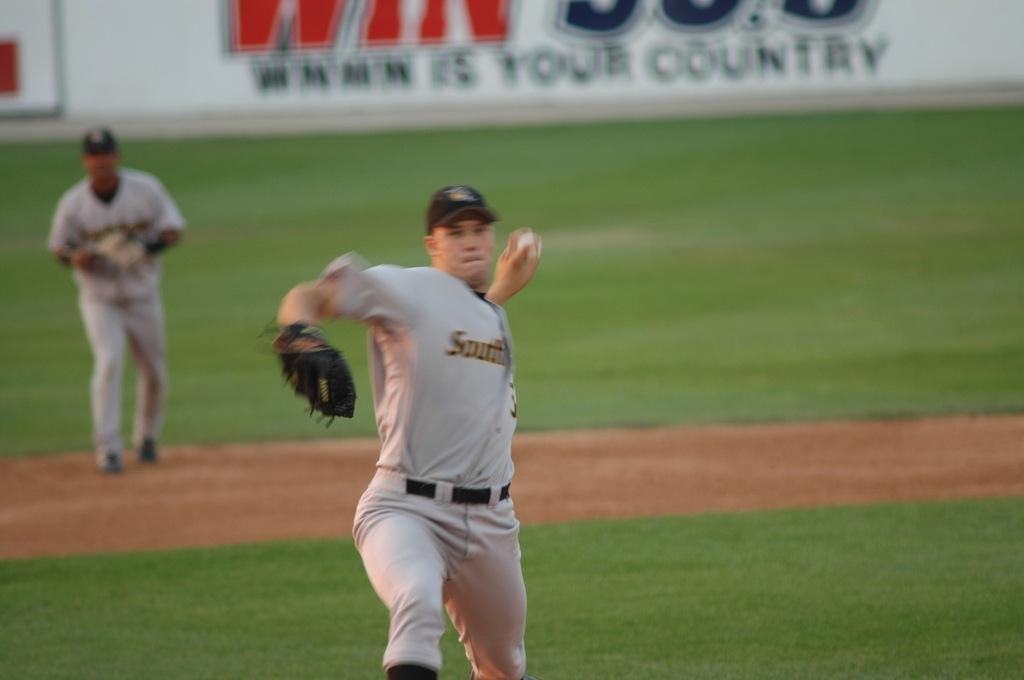<image>
Describe the image concisely. A pitcher wearing a jersey with the word South on the front throws a baseball. 